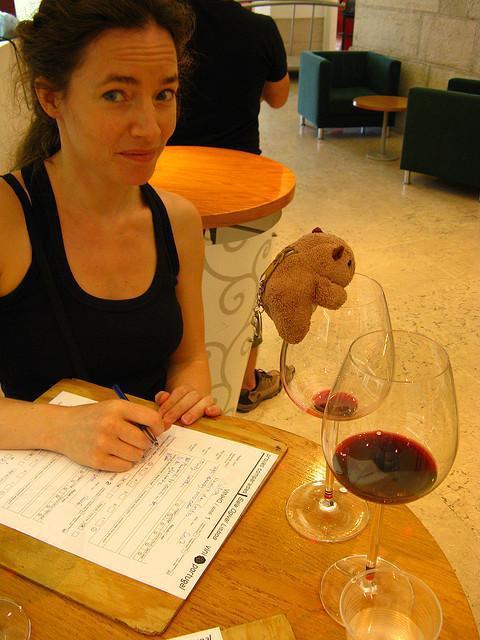How many dining tables are there?
Give a very brief answer. 2. How many wine glasses are in the picture?
Give a very brief answer. 2. How many people are there?
Give a very brief answer. 2. How many chairs are in the photo?
Give a very brief answer. 2. How many rolls of toilet paper are there?
Give a very brief answer. 0. 